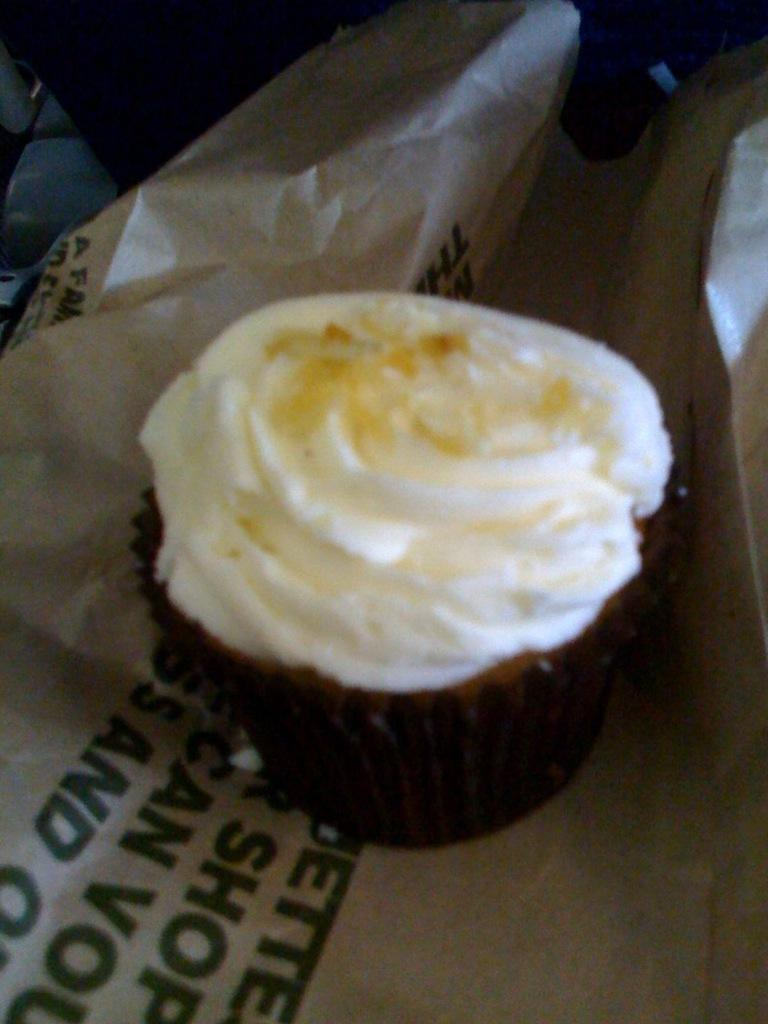What type of dessert is visible in the image? There is a cupcake in the image. How is the cupcake presented in the image? The cupcake is placed on a paper cover. What type of curtain is hanging in the background of the image? There is no curtain visible in the image; it only features a cupcake on a paper cover. 